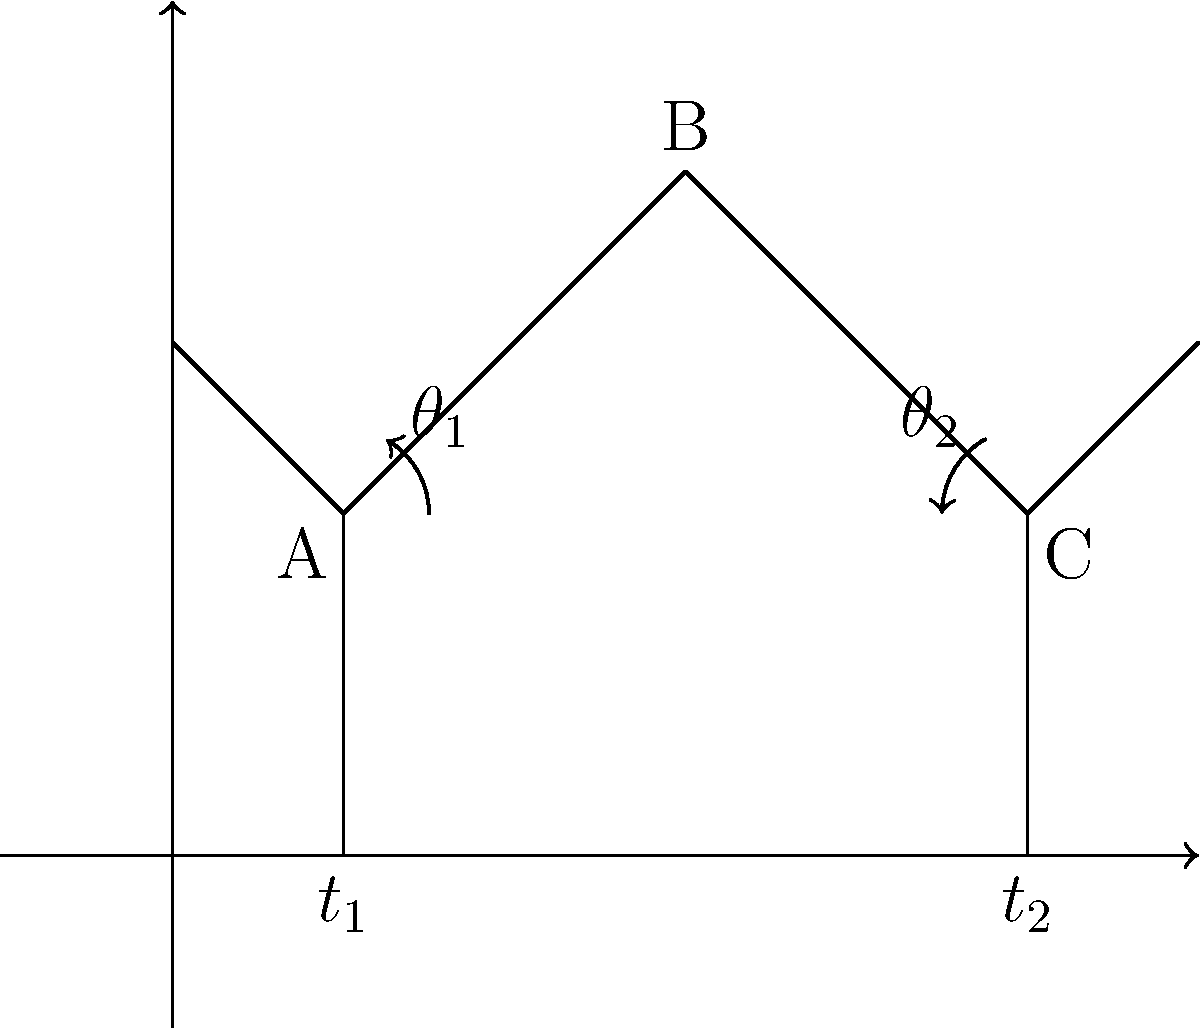In the stick figure diagram representing two time points ($t_1$ and $t_2$) during a gait cycle, joint angles $\theta_1$ and $\theta_2$ are shown. How would you critique the assumption that these angles alone are sufficient to determine muscle length changes between the two time points? To critically analyze this problem, we need to consider several factors that challenge the assumption that joint angles alone are sufficient to determine muscle length changes:

1. Muscle-tendon unit complexity: Muscles often span multiple joints, and their length is influenced by the angles of all joints they cross. The diagram only shows two angles, which may not capture all relevant joint movements.

2. Muscle architecture: Pennation angle and fiber length can change independently of joint angle, affecting overall muscle length. This information is not captured in a simple stick figure diagram.

3. Three-dimensional motion: Gait involves movement in multiple planes, but the stick figure only represents motion in two dimensions. This simplification may lead to errors in muscle length estimation.

4. Co-contraction: Antagonistic muscles may contract simultaneously, affecting their lengths in ways not reflected by joint angles alone.

5. Tendon elasticity: Tendons can stretch or recoil, changing the effective length of the muscle-tendon unit without necessarily changing joint angles.

6. Non-linear relationship: The relationship between joint angle and muscle length is often non-linear, especially near the extremes of joint motion.

7. Individual variations: Factors such as limb length, muscle insertion points, and joint structure vary between individuals, making generalizations based on joint angles problematic.

8. Dynamic nature of gait: The diagram represents only two static time points, neglecting the continuous nature of muscle length changes during gait.

9. Neglect of other gait parameters: Factors such as walking speed, stride length, and ground reaction forces also influence muscle dynamics but are not represented in the diagram.

10. Simplification of joint centers: The stick figure assumes simple hinge joints, whereas real joints have more complex axes of rotation that can shift during movement.

These limitations demonstrate that while joint angles provide some information about muscle length changes, they are insufficient for a comprehensive analysis of muscle dynamics during gait.
Answer: Joint angles alone are insufficient; muscle-tendon dynamics, 3D motion, co-contraction, tendon elasticity, and individual variations are neglected. 